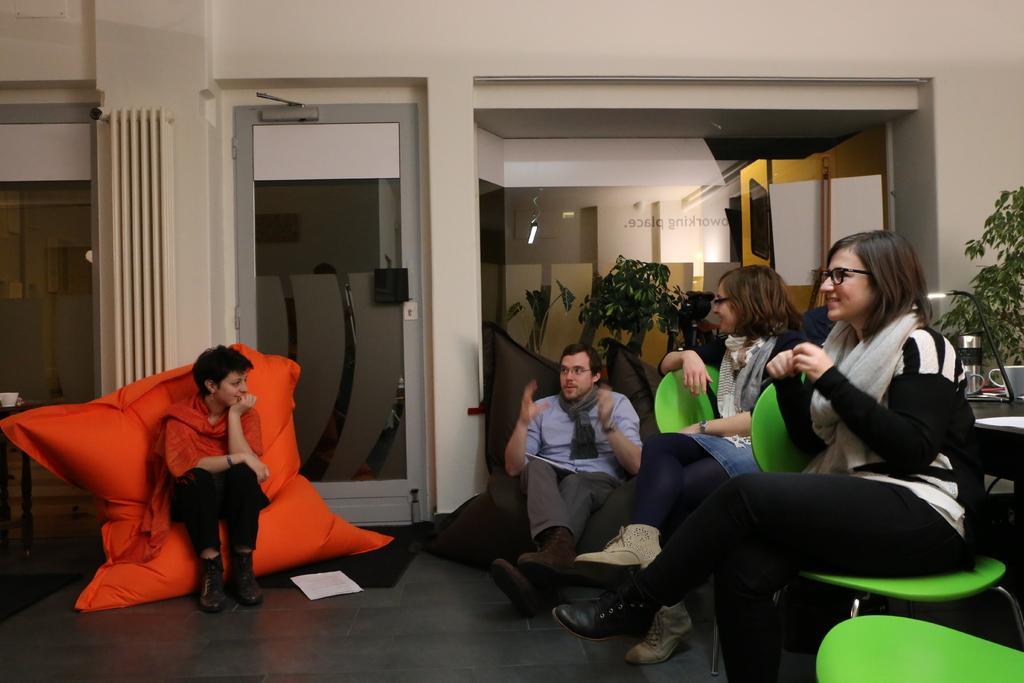Can you describe this image briefly? In this picture there are people sitting on sofas and chairs ,in the background we observe glass door and a curtain. 